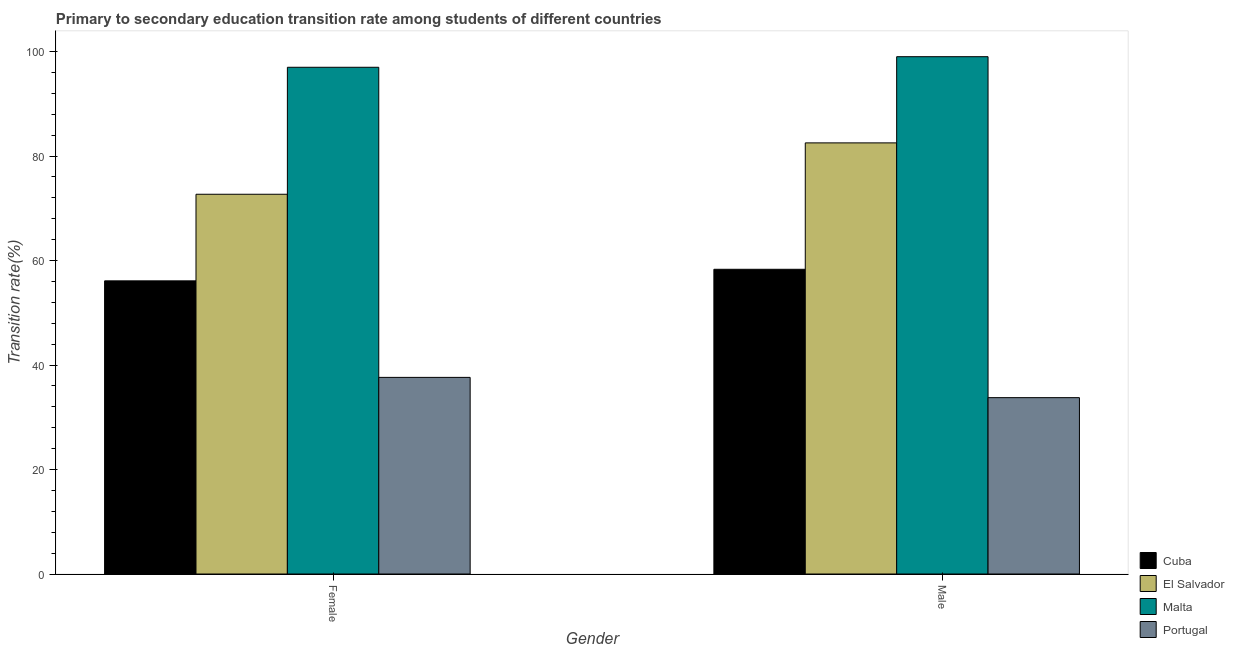How many different coloured bars are there?
Keep it short and to the point. 4. How many groups of bars are there?
Your answer should be compact. 2. Are the number of bars per tick equal to the number of legend labels?
Give a very brief answer. Yes. Are the number of bars on each tick of the X-axis equal?
Your answer should be very brief. Yes. What is the transition rate among female students in Portugal?
Provide a short and direct response. 37.64. Across all countries, what is the maximum transition rate among female students?
Make the answer very short. 96.99. Across all countries, what is the minimum transition rate among male students?
Make the answer very short. 33.76. In which country was the transition rate among female students maximum?
Offer a very short reply. Malta. In which country was the transition rate among female students minimum?
Offer a terse response. Portugal. What is the total transition rate among male students in the graph?
Keep it short and to the point. 273.62. What is the difference between the transition rate among female students in Cuba and that in Portugal?
Your answer should be very brief. 18.48. What is the difference between the transition rate among female students in Portugal and the transition rate among male students in El Salvador?
Offer a terse response. -44.89. What is the average transition rate among male students per country?
Ensure brevity in your answer.  68.41. What is the difference between the transition rate among female students and transition rate among male students in Portugal?
Provide a short and direct response. 3.88. In how many countries, is the transition rate among male students greater than 40 %?
Ensure brevity in your answer.  3. What is the ratio of the transition rate among male students in Portugal to that in Malta?
Provide a succinct answer. 0.34. Is the transition rate among female students in Portugal less than that in Cuba?
Provide a short and direct response. Yes. In how many countries, is the transition rate among male students greater than the average transition rate among male students taken over all countries?
Keep it short and to the point. 2. What does the 2nd bar from the left in Male represents?
Your answer should be compact. El Salvador. What does the 3rd bar from the right in Female represents?
Offer a terse response. El Salvador. How many bars are there?
Your answer should be compact. 8. Are all the bars in the graph horizontal?
Give a very brief answer. No. Does the graph contain any zero values?
Your answer should be very brief. No. Does the graph contain grids?
Your answer should be very brief. No. Where does the legend appear in the graph?
Your answer should be very brief. Bottom right. How many legend labels are there?
Provide a short and direct response. 4. What is the title of the graph?
Make the answer very short. Primary to secondary education transition rate among students of different countries. What is the label or title of the X-axis?
Offer a terse response. Gender. What is the label or title of the Y-axis?
Give a very brief answer. Transition rate(%). What is the Transition rate(%) in Cuba in Female?
Your answer should be very brief. 56.11. What is the Transition rate(%) in El Salvador in Female?
Offer a terse response. 72.69. What is the Transition rate(%) in Malta in Female?
Your response must be concise. 96.99. What is the Transition rate(%) of Portugal in Female?
Offer a terse response. 37.64. What is the Transition rate(%) of Cuba in Male?
Your answer should be very brief. 58.33. What is the Transition rate(%) in El Salvador in Male?
Your answer should be very brief. 82.52. What is the Transition rate(%) in Malta in Male?
Ensure brevity in your answer.  99.02. What is the Transition rate(%) in Portugal in Male?
Your answer should be very brief. 33.76. Across all Gender, what is the maximum Transition rate(%) of Cuba?
Make the answer very short. 58.33. Across all Gender, what is the maximum Transition rate(%) of El Salvador?
Keep it short and to the point. 82.52. Across all Gender, what is the maximum Transition rate(%) of Malta?
Your answer should be very brief. 99.02. Across all Gender, what is the maximum Transition rate(%) of Portugal?
Keep it short and to the point. 37.64. Across all Gender, what is the minimum Transition rate(%) of Cuba?
Offer a terse response. 56.11. Across all Gender, what is the minimum Transition rate(%) of El Salvador?
Your answer should be very brief. 72.69. Across all Gender, what is the minimum Transition rate(%) in Malta?
Ensure brevity in your answer.  96.99. Across all Gender, what is the minimum Transition rate(%) in Portugal?
Your response must be concise. 33.76. What is the total Transition rate(%) in Cuba in the graph?
Your answer should be compact. 114.44. What is the total Transition rate(%) of El Salvador in the graph?
Make the answer very short. 155.21. What is the total Transition rate(%) of Malta in the graph?
Provide a short and direct response. 196.01. What is the total Transition rate(%) in Portugal in the graph?
Make the answer very short. 71.39. What is the difference between the Transition rate(%) of Cuba in Female and that in Male?
Keep it short and to the point. -2.21. What is the difference between the Transition rate(%) in El Salvador in Female and that in Male?
Ensure brevity in your answer.  -9.83. What is the difference between the Transition rate(%) of Malta in Female and that in Male?
Keep it short and to the point. -2.03. What is the difference between the Transition rate(%) of Portugal in Female and that in Male?
Offer a very short reply. 3.88. What is the difference between the Transition rate(%) of Cuba in Female and the Transition rate(%) of El Salvador in Male?
Make the answer very short. -26.41. What is the difference between the Transition rate(%) in Cuba in Female and the Transition rate(%) in Malta in Male?
Provide a succinct answer. -42.91. What is the difference between the Transition rate(%) in Cuba in Female and the Transition rate(%) in Portugal in Male?
Offer a terse response. 22.36. What is the difference between the Transition rate(%) in El Salvador in Female and the Transition rate(%) in Malta in Male?
Your response must be concise. -26.33. What is the difference between the Transition rate(%) of El Salvador in Female and the Transition rate(%) of Portugal in Male?
Your answer should be very brief. 38.93. What is the difference between the Transition rate(%) of Malta in Female and the Transition rate(%) of Portugal in Male?
Give a very brief answer. 63.24. What is the average Transition rate(%) of Cuba per Gender?
Your answer should be very brief. 57.22. What is the average Transition rate(%) in El Salvador per Gender?
Offer a very short reply. 77.61. What is the average Transition rate(%) in Malta per Gender?
Make the answer very short. 98.01. What is the average Transition rate(%) of Portugal per Gender?
Ensure brevity in your answer.  35.7. What is the difference between the Transition rate(%) in Cuba and Transition rate(%) in El Salvador in Female?
Offer a terse response. -16.58. What is the difference between the Transition rate(%) in Cuba and Transition rate(%) in Malta in Female?
Your response must be concise. -40.88. What is the difference between the Transition rate(%) of Cuba and Transition rate(%) of Portugal in Female?
Make the answer very short. 18.48. What is the difference between the Transition rate(%) in El Salvador and Transition rate(%) in Malta in Female?
Provide a short and direct response. -24.31. What is the difference between the Transition rate(%) of El Salvador and Transition rate(%) of Portugal in Female?
Your response must be concise. 35.05. What is the difference between the Transition rate(%) of Malta and Transition rate(%) of Portugal in Female?
Your answer should be compact. 59.36. What is the difference between the Transition rate(%) of Cuba and Transition rate(%) of El Salvador in Male?
Give a very brief answer. -24.2. What is the difference between the Transition rate(%) of Cuba and Transition rate(%) of Malta in Male?
Your response must be concise. -40.69. What is the difference between the Transition rate(%) in Cuba and Transition rate(%) in Portugal in Male?
Provide a succinct answer. 24.57. What is the difference between the Transition rate(%) of El Salvador and Transition rate(%) of Malta in Male?
Ensure brevity in your answer.  -16.5. What is the difference between the Transition rate(%) of El Salvador and Transition rate(%) of Portugal in Male?
Keep it short and to the point. 48.77. What is the difference between the Transition rate(%) in Malta and Transition rate(%) in Portugal in Male?
Provide a short and direct response. 65.26. What is the ratio of the Transition rate(%) of Cuba in Female to that in Male?
Your answer should be very brief. 0.96. What is the ratio of the Transition rate(%) in El Salvador in Female to that in Male?
Ensure brevity in your answer.  0.88. What is the ratio of the Transition rate(%) of Malta in Female to that in Male?
Ensure brevity in your answer.  0.98. What is the ratio of the Transition rate(%) in Portugal in Female to that in Male?
Your response must be concise. 1.11. What is the difference between the highest and the second highest Transition rate(%) of Cuba?
Offer a terse response. 2.21. What is the difference between the highest and the second highest Transition rate(%) of El Salvador?
Give a very brief answer. 9.83. What is the difference between the highest and the second highest Transition rate(%) in Malta?
Provide a succinct answer. 2.03. What is the difference between the highest and the second highest Transition rate(%) in Portugal?
Make the answer very short. 3.88. What is the difference between the highest and the lowest Transition rate(%) of Cuba?
Offer a terse response. 2.21. What is the difference between the highest and the lowest Transition rate(%) in El Salvador?
Offer a terse response. 9.83. What is the difference between the highest and the lowest Transition rate(%) of Malta?
Your response must be concise. 2.03. What is the difference between the highest and the lowest Transition rate(%) in Portugal?
Ensure brevity in your answer.  3.88. 